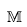<formula> <loc_0><loc_0><loc_500><loc_500>\mathbb { M }</formula> 